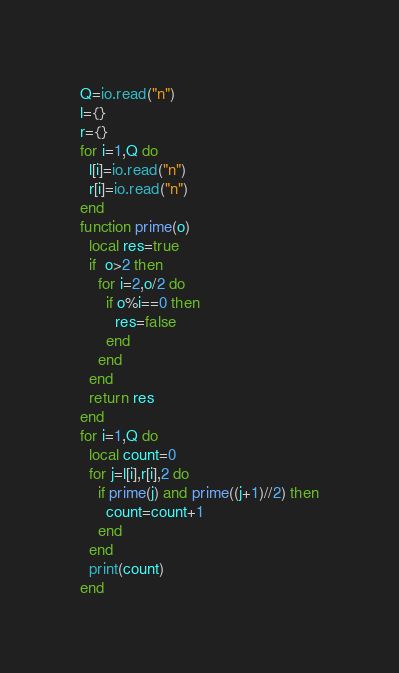Convert code to text. <code><loc_0><loc_0><loc_500><loc_500><_Lua_>Q=io.read("n")
l={}
r={}
for i=1,Q do
  l[i]=io.read("n")
  r[i]=io.read("n")
end
function prime(o)
  local res=true
  if  o>2 then
    for i=2,o/2 do
      if o%i==0 then
        res=false
      end
    end
  end
  return res
end
for i=1,Q do
  local count=0
  for j=l[i],r[i],2 do
    if prime(j) and prime((j+1)//2) then
      count=count+1
    end
  end
  print(count)
end</code> 